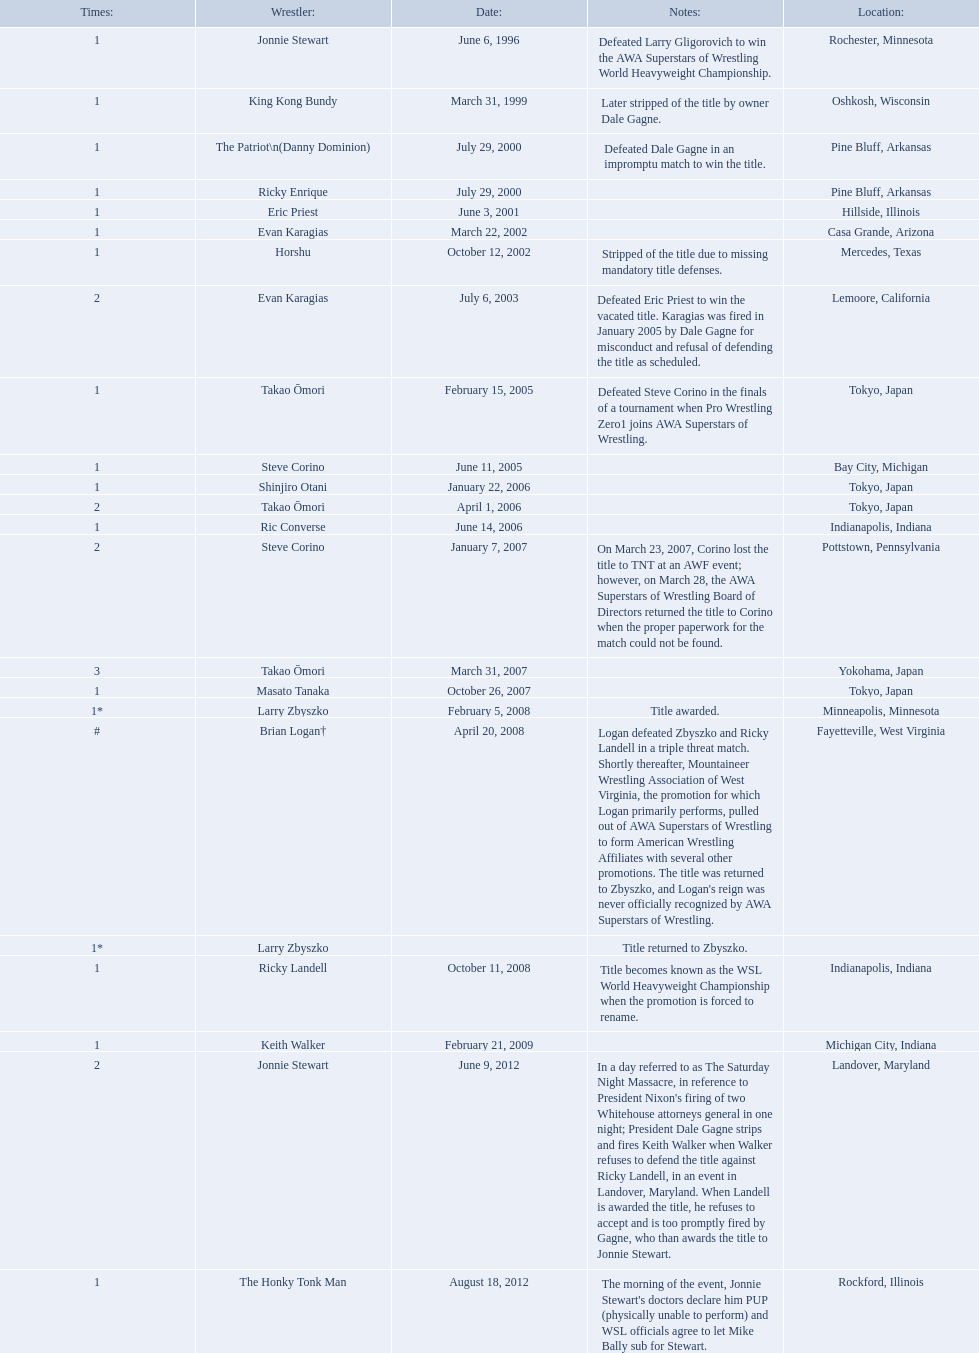Who are all of the wrestlers? Jonnie Stewart, King Kong Bundy, The Patriot\n(Danny Dominion), Ricky Enrique, Eric Priest, Evan Karagias, Horshu, Evan Karagias, Takao Ōmori, Steve Corino, Shinjiro Otani, Takao Ōmori, Ric Converse, Steve Corino, Takao Ōmori, Masato Tanaka, Larry Zbyszko, Brian Logan†, Larry Zbyszko, Ricky Landell, Keith Walker, Jonnie Stewart, The Honky Tonk Man. Where are they from? Rochester, Minnesota, Oshkosh, Wisconsin, Pine Bluff, Arkansas, Pine Bluff, Arkansas, Hillside, Illinois, Casa Grande, Arizona, Mercedes, Texas, Lemoore, California, Tokyo, Japan, Bay City, Michigan, Tokyo, Japan, Tokyo, Japan, Indianapolis, Indiana, Pottstown, Pennsylvania, Yokohama, Japan, Tokyo, Japan, Minneapolis, Minnesota, Fayetteville, West Virginia, , Indianapolis, Indiana, Michigan City, Indiana, Landover, Maryland, Rockford, Illinois. And which of them is from texas? Horshu. Who are the wrestlers? Jonnie Stewart, Rochester, Minnesota, King Kong Bundy, Oshkosh, Wisconsin, The Patriot\n(Danny Dominion), Pine Bluff, Arkansas, Ricky Enrique, Pine Bluff, Arkansas, Eric Priest, Hillside, Illinois, Evan Karagias, Casa Grande, Arizona, Horshu, Mercedes, Texas, Evan Karagias, Lemoore, California, Takao Ōmori, Tokyo, Japan, Steve Corino, Bay City, Michigan, Shinjiro Otani, Tokyo, Japan, Takao Ōmori, Tokyo, Japan, Ric Converse, Indianapolis, Indiana, Steve Corino, Pottstown, Pennsylvania, Takao Ōmori, Yokohama, Japan, Masato Tanaka, Tokyo, Japan, Larry Zbyszko, Minneapolis, Minnesota, Brian Logan†, Fayetteville, West Virginia, Larry Zbyszko, , Ricky Landell, Indianapolis, Indiana, Keith Walker, Michigan City, Indiana, Jonnie Stewart, Landover, Maryland, The Honky Tonk Man, Rockford, Illinois. Who was from texas? Horshu, Mercedes, Texas. Who is he? Horshu. 